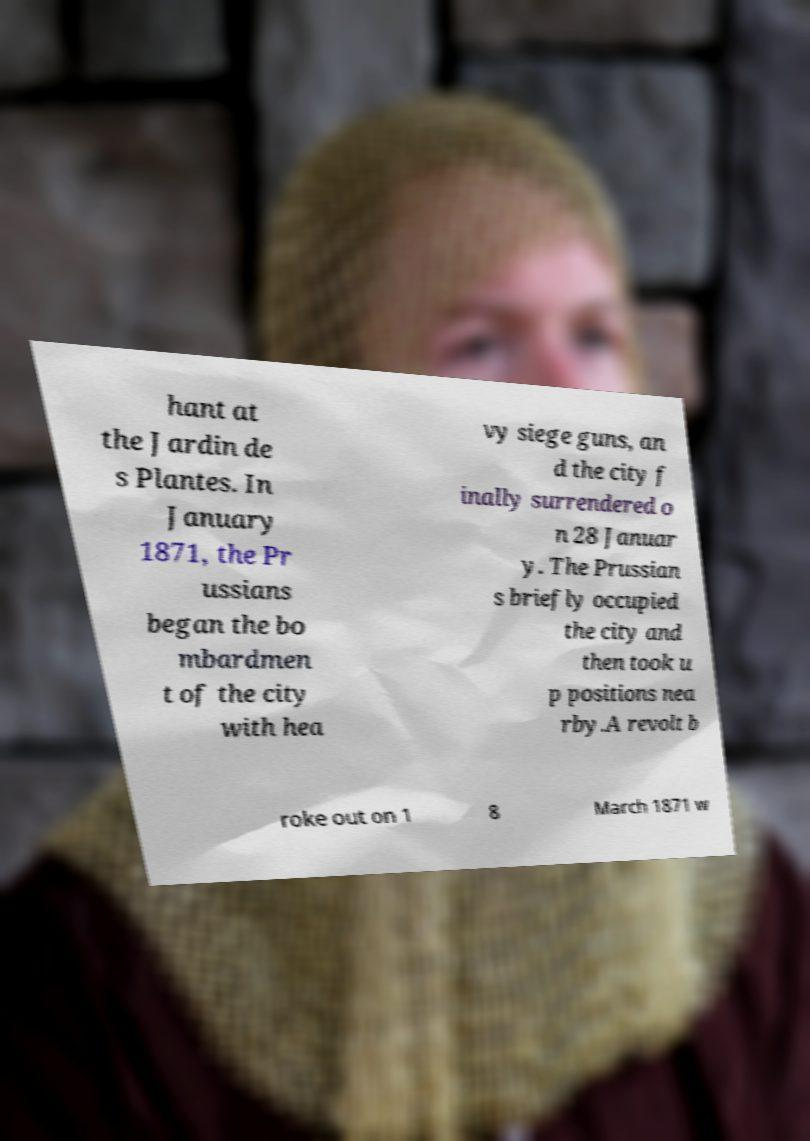Can you read and provide the text displayed in the image?This photo seems to have some interesting text. Can you extract and type it out for me? hant at the Jardin de s Plantes. In January 1871, the Pr ussians began the bo mbardmen t of the city with hea vy siege guns, an d the city f inally surrendered o n 28 Januar y. The Prussian s briefly occupied the city and then took u p positions nea rby.A revolt b roke out on 1 8 March 1871 w 